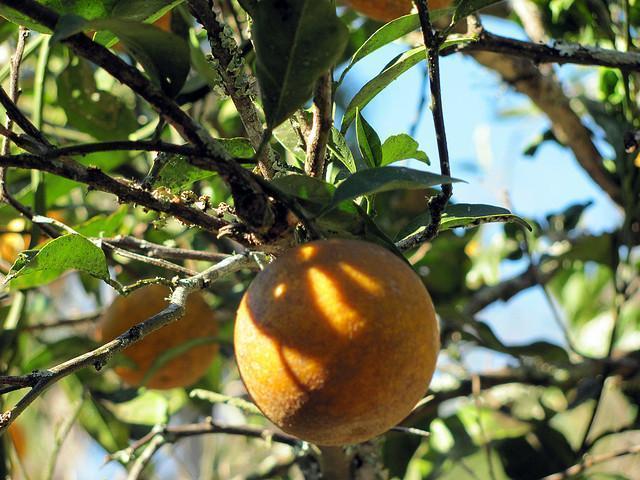Which acid is present in orange?
Make your selection from the four choices given to correctly answer the question.
Options: Tannic acid, citric acid, tartaric acid, amino acid. Citric acid. 